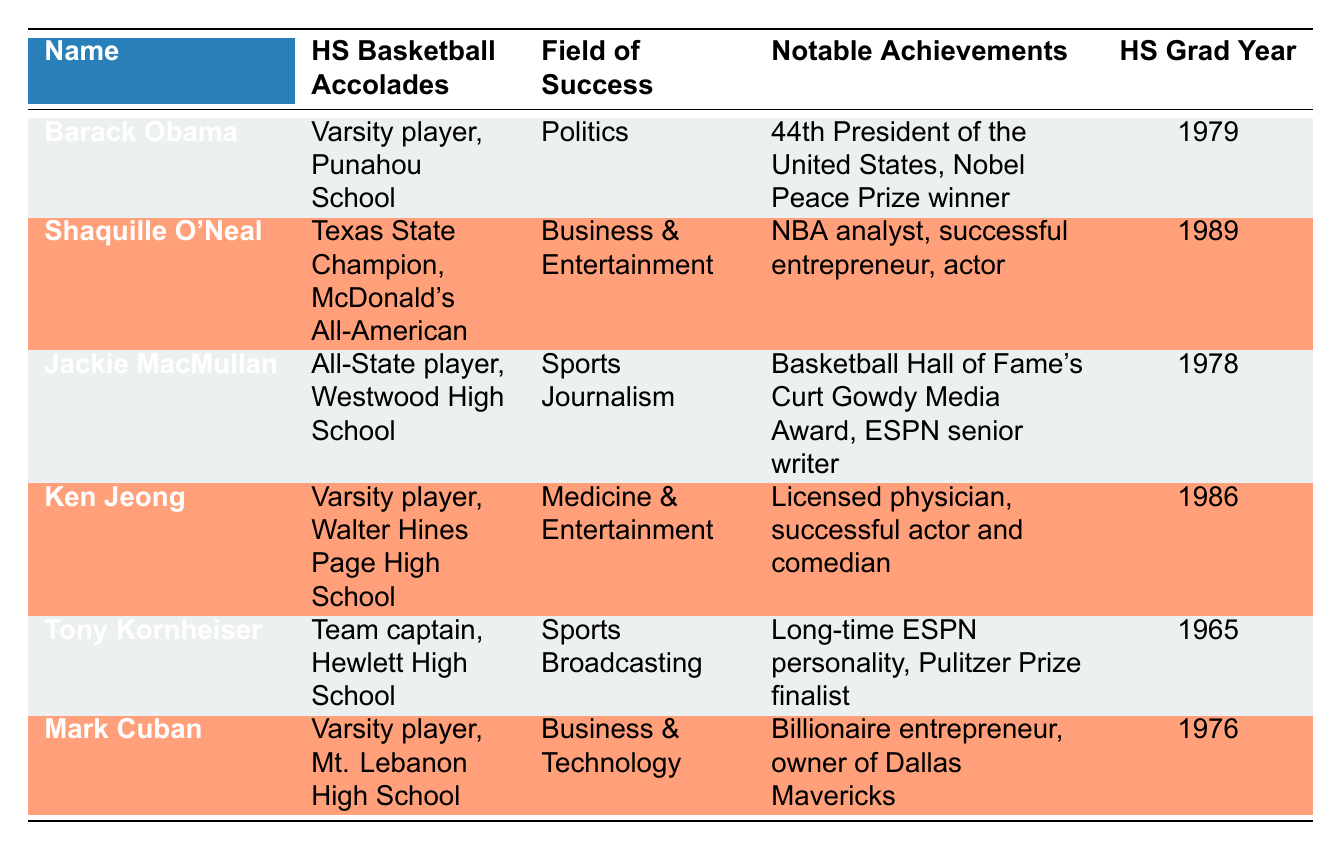What high school did Barack Obama graduate from? According to the table, Barack Obama graduated from Punahou School as a varsity player.
Answer: Punahou School Who graduated from high school in 1986? The table shows that Ken Jeong graduated in 1986 as a varsity player from Walter Hines Page High School.
Answer: Ken Jeong Did Tony Kornheiser achieve any notable accomplishments in sports broadcasting? Yes, according to the table, Tony Kornheiser is a long-time ESPN personality and a Pulitzer Prize finalist, which are significant accomplishments in his field.
Answer: Yes How many individuals listed in the table are associated with Business & Entertainment? The table provides 2 names in that category: Shaquille O'Neal and Ken Jeong. Therefore, the count of individuals in this field is 2.
Answer: 2 Which individual has the most notable achievement related to politics? Barack Obama is noted as the 44th President of the United States and a Nobel Peace Prize winner, making him the standout individual in politics.
Answer: Barack Obama What is the average year of high school graduation for the individuals listed? The graduation years are: 1979, 1989, 1978, 1986, 1965, and 1976. Adding these together gives 1973, then dividing by 6 (total number of graduates) results in an average graduation year of about 1976.
Answer: 1976 Was any player unanimously recognized in the Basketball Hall of Fame? Yes, Jackie MacMullan received the Basketball Hall of Fame's Curt Gowdy Media Award, indicating significant recognition in sports journalism.
Answer: Yes Which former player transitioned into sports journalism? The table specifies that Jackie MacMullan transitioned into sports journalism and has notable achievements in that field.
Answer: Jackie MacMullan How many of the individuals listed were varsity players in high school? The table indicates that 4 individuals (Barack Obama, Ken Jeong, Tony Kornheiser, and Mark Cuban) were noted to have been varsity players in high school.
Answer: 4 Which field does Mark Cuban succeed in? The table lists Mark Cuban's field of success as Business & Technology, where he has become a billionaire entrepreneur and owner of the Dallas Mavericks.
Answer: Business & Technology 